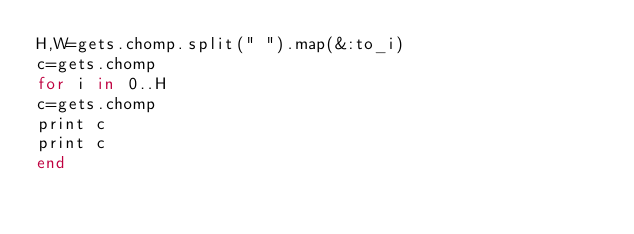<code> <loc_0><loc_0><loc_500><loc_500><_Ruby_>H,W=gets.chomp.split(" ").map(&:to_i)
c=gets.chomp
for i in 0..H
c=gets.chomp
print c
print c
end</code> 